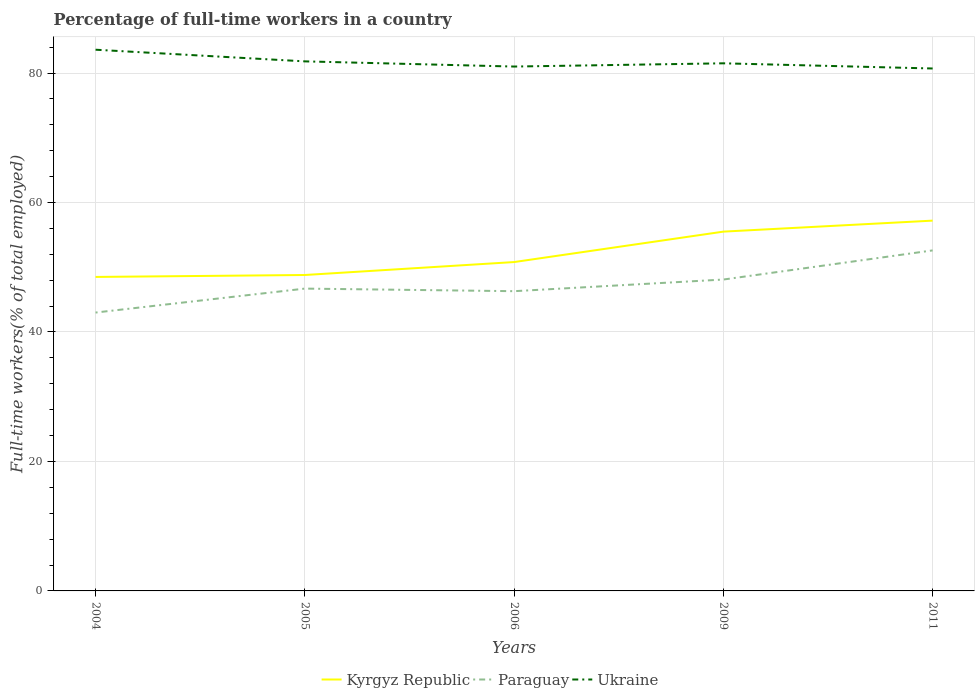How many different coloured lines are there?
Your response must be concise. 3. Does the line corresponding to Ukraine intersect with the line corresponding to Paraguay?
Provide a short and direct response. No. Across all years, what is the maximum percentage of full-time workers in Ukraine?
Your response must be concise. 80.7. What is the total percentage of full-time workers in Ukraine in the graph?
Keep it short and to the point. 2.6. What is the difference between the highest and the second highest percentage of full-time workers in Paraguay?
Your answer should be compact. 9.6. What is the difference between the highest and the lowest percentage of full-time workers in Paraguay?
Give a very brief answer. 2. Is the percentage of full-time workers in Paraguay strictly greater than the percentage of full-time workers in Kyrgyz Republic over the years?
Ensure brevity in your answer.  Yes. How many years are there in the graph?
Your response must be concise. 5. What is the difference between two consecutive major ticks on the Y-axis?
Your answer should be compact. 20. Does the graph contain any zero values?
Keep it short and to the point. No. How many legend labels are there?
Your answer should be very brief. 3. What is the title of the graph?
Offer a very short reply. Percentage of full-time workers in a country. What is the label or title of the X-axis?
Your response must be concise. Years. What is the label or title of the Y-axis?
Provide a succinct answer. Full-time workers(% of total employed). What is the Full-time workers(% of total employed) of Kyrgyz Republic in 2004?
Provide a short and direct response. 48.5. What is the Full-time workers(% of total employed) of Paraguay in 2004?
Ensure brevity in your answer.  43. What is the Full-time workers(% of total employed) of Ukraine in 2004?
Keep it short and to the point. 83.6. What is the Full-time workers(% of total employed) of Kyrgyz Republic in 2005?
Offer a very short reply. 48.8. What is the Full-time workers(% of total employed) in Paraguay in 2005?
Provide a short and direct response. 46.7. What is the Full-time workers(% of total employed) of Ukraine in 2005?
Offer a very short reply. 81.8. What is the Full-time workers(% of total employed) in Kyrgyz Republic in 2006?
Your response must be concise. 50.8. What is the Full-time workers(% of total employed) of Paraguay in 2006?
Ensure brevity in your answer.  46.3. What is the Full-time workers(% of total employed) in Ukraine in 2006?
Your answer should be very brief. 81. What is the Full-time workers(% of total employed) in Kyrgyz Republic in 2009?
Keep it short and to the point. 55.5. What is the Full-time workers(% of total employed) in Paraguay in 2009?
Provide a succinct answer. 48.1. What is the Full-time workers(% of total employed) of Ukraine in 2009?
Your response must be concise. 81.5. What is the Full-time workers(% of total employed) in Kyrgyz Republic in 2011?
Provide a succinct answer. 57.2. What is the Full-time workers(% of total employed) of Paraguay in 2011?
Your response must be concise. 52.6. What is the Full-time workers(% of total employed) of Ukraine in 2011?
Your answer should be compact. 80.7. Across all years, what is the maximum Full-time workers(% of total employed) of Kyrgyz Republic?
Provide a succinct answer. 57.2. Across all years, what is the maximum Full-time workers(% of total employed) of Paraguay?
Offer a terse response. 52.6. Across all years, what is the maximum Full-time workers(% of total employed) of Ukraine?
Offer a terse response. 83.6. Across all years, what is the minimum Full-time workers(% of total employed) in Kyrgyz Republic?
Your answer should be very brief. 48.5. Across all years, what is the minimum Full-time workers(% of total employed) in Paraguay?
Your response must be concise. 43. Across all years, what is the minimum Full-time workers(% of total employed) in Ukraine?
Make the answer very short. 80.7. What is the total Full-time workers(% of total employed) in Kyrgyz Republic in the graph?
Your response must be concise. 260.8. What is the total Full-time workers(% of total employed) in Paraguay in the graph?
Keep it short and to the point. 236.7. What is the total Full-time workers(% of total employed) of Ukraine in the graph?
Ensure brevity in your answer.  408.6. What is the difference between the Full-time workers(% of total employed) in Paraguay in 2004 and that in 2005?
Make the answer very short. -3.7. What is the difference between the Full-time workers(% of total employed) of Ukraine in 2004 and that in 2009?
Keep it short and to the point. 2.1. What is the difference between the Full-time workers(% of total employed) of Kyrgyz Republic in 2004 and that in 2011?
Your answer should be compact. -8.7. What is the difference between the Full-time workers(% of total employed) in Paraguay in 2004 and that in 2011?
Provide a short and direct response. -9.6. What is the difference between the Full-time workers(% of total employed) of Kyrgyz Republic in 2005 and that in 2006?
Provide a short and direct response. -2. What is the difference between the Full-time workers(% of total employed) in Ukraine in 2005 and that in 2006?
Provide a short and direct response. 0.8. What is the difference between the Full-time workers(% of total employed) of Ukraine in 2006 and that in 2009?
Keep it short and to the point. -0.5. What is the difference between the Full-time workers(% of total employed) of Paraguay in 2006 and that in 2011?
Make the answer very short. -6.3. What is the difference between the Full-time workers(% of total employed) of Kyrgyz Republic in 2004 and the Full-time workers(% of total employed) of Paraguay in 2005?
Your answer should be very brief. 1.8. What is the difference between the Full-time workers(% of total employed) of Kyrgyz Republic in 2004 and the Full-time workers(% of total employed) of Ukraine in 2005?
Offer a terse response. -33.3. What is the difference between the Full-time workers(% of total employed) of Paraguay in 2004 and the Full-time workers(% of total employed) of Ukraine in 2005?
Ensure brevity in your answer.  -38.8. What is the difference between the Full-time workers(% of total employed) in Kyrgyz Republic in 2004 and the Full-time workers(% of total employed) in Paraguay in 2006?
Provide a succinct answer. 2.2. What is the difference between the Full-time workers(% of total employed) of Kyrgyz Republic in 2004 and the Full-time workers(% of total employed) of Ukraine in 2006?
Provide a short and direct response. -32.5. What is the difference between the Full-time workers(% of total employed) in Paraguay in 2004 and the Full-time workers(% of total employed) in Ukraine in 2006?
Your response must be concise. -38. What is the difference between the Full-time workers(% of total employed) of Kyrgyz Republic in 2004 and the Full-time workers(% of total employed) of Paraguay in 2009?
Your answer should be compact. 0.4. What is the difference between the Full-time workers(% of total employed) in Kyrgyz Republic in 2004 and the Full-time workers(% of total employed) in Ukraine in 2009?
Keep it short and to the point. -33. What is the difference between the Full-time workers(% of total employed) in Paraguay in 2004 and the Full-time workers(% of total employed) in Ukraine in 2009?
Offer a terse response. -38.5. What is the difference between the Full-time workers(% of total employed) of Kyrgyz Republic in 2004 and the Full-time workers(% of total employed) of Ukraine in 2011?
Give a very brief answer. -32.2. What is the difference between the Full-time workers(% of total employed) of Paraguay in 2004 and the Full-time workers(% of total employed) of Ukraine in 2011?
Give a very brief answer. -37.7. What is the difference between the Full-time workers(% of total employed) of Kyrgyz Republic in 2005 and the Full-time workers(% of total employed) of Ukraine in 2006?
Provide a succinct answer. -32.2. What is the difference between the Full-time workers(% of total employed) in Paraguay in 2005 and the Full-time workers(% of total employed) in Ukraine in 2006?
Give a very brief answer. -34.3. What is the difference between the Full-time workers(% of total employed) of Kyrgyz Republic in 2005 and the Full-time workers(% of total employed) of Ukraine in 2009?
Offer a very short reply. -32.7. What is the difference between the Full-time workers(% of total employed) in Paraguay in 2005 and the Full-time workers(% of total employed) in Ukraine in 2009?
Offer a very short reply. -34.8. What is the difference between the Full-time workers(% of total employed) of Kyrgyz Republic in 2005 and the Full-time workers(% of total employed) of Paraguay in 2011?
Provide a short and direct response. -3.8. What is the difference between the Full-time workers(% of total employed) of Kyrgyz Republic in 2005 and the Full-time workers(% of total employed) of Ukraine in 2011?
Ensure brevity in your answer.  -31.9. What is the difference between the Full-time workers(% of total employed) in Paraguay in 2005 and the Full-time workers(% of total employed) in Ukraine in 2011?
Make the answer very short. -34. What is the difference between the Full-time workers(% of total employed) of Kyrgyz Republic in 2006 and the Full-time workers(% of total employed) of Ukraine in 2009?
Make the answer very short. -30.7. What is the difference between the Full-time workers(% of total employed) in Paraguay in 2006 and the Full-time workers(% of total employed) in Ukraine in 2009?
Your response must be concise. -35.2. What is the difference between the Full-time workers(% of total employed) of Kyrgyz Republic in 2006 and the Full-time workers(% of total employed) of Ukraine in 2011?
Provide a succinct answer. -29.9. What is the difference between the Full-time workers(% of total employed) of Paraguay in 2006 and the Full-time workers(% of total employed) of Ukraine in 2011?
Make the answer very short. -34.4. What is the difference between the Full-time workers(% of total employed) in Kyrgyz Republic in 2009 and the Full-time workers(% of total employed) in Paraguay in 2011?
Your answer should be very brief. 2.9. What is the difference between the Full-time workers(% of total employed) of Kyrgyz Republic in 2009 and the Full-time workers(% of total employed) of Ukraine in 2011?
Your response must be concise. -25.2. What is the difference between the Full-time workers(% of total employed) in Paraguay in 2009 and the Full-time workers(% of total employed) in Ukraine in 2011?
Provide a short and direct response. -32.6. What is the average Full-time workers(% of total employed) of Kyrgyz Republic per year?
Offer a terse response. 52.16. What is the average Full-time workers(% of total employed) in Paraguay per year?
Provide a succinct answer. 47.34. What is the average Full-time workers(% of total employed) in Ukraine per year?
Your response must be concise. 81.72. In the year 2004, what is the difference between the Full-time workers(% of total employed) of Kyrgyz Republic and Full-time workers(% of total employed) of Paraguay?
Your answer should be very brief. 5.5. In the year 2004, what is the difference between the Full-time workers(% of total employed) of Kyrgyz Republic and Full-time workers(% of total employed) of Ukraine?
Make the answer very short. -35.1. In the year 2004, what is the difference between the Full-time workers(% of total employed) in Paraguay and Full-time workers(% of total employed) in Ukraine?
Make the answer very short. -40.6. In the year 2005, what is the difference between the Full-time workers(% of total employed) in Kyrgyz Republic and Full-time workers(% of total employed) in Paraguay?
Your answer should be very brief. 2.1. In the year 2005, what is the difference between the Full-time workers(% of total employed) in Kyrgyz Republic and Full-time workers(% of total employed) in Ukraine?
Give a very brief answer. -33. In the year 2005, what is the difference between the Full-time workers(% of total employed) of Paraguay and Full-time workers(% of total employed) of Ukraine?
Your response must be concise. -35.1. In the year 2006, what is the difference between the Full-time workers(% of total employed) in Kyrgyz Republic and Full-time workers(% of total employed) in Ukraine?
Your response must be concise. -30.2. In the year 2006, what is the difference between the Full-time workers(% of total employed) of Paraguay and Full-time workers(% of total employed) of Ukraine?
Provide a succinct answer. -34.7. In the year 2009, what is the difference between the Full-time workers(% of total employed) in Kyrgyz Republic and Full-time workers(% of total employed) in Paraguay?
Ensure brevity in your answer.  7.4. In the year 2009, what is the difference between the Full-time workers(% of total employed) of Paraguay and Full-time workers(% of total employed) of Ukraine?
Your answer should be compact. -33.4. In the year 2011, what is the difference between the Full-time workers(% of total employed) of Kyrgyz Republic and Full-time workers(% of total employed) of Paraguay?
Give a very brief answer. 4.6. In the year 2011, what is the difference between the Full-time workers(% of total employed) of Kyrgyz Republic and Full-time workers(% of total employed) of Ukraine?
Your response must be concise. -23.5. In the year 2011, what is the difference between the Full-time workers(% of total employed) of Paraguay and Full-time workers(% of total employed) of Ukraine?
Offer a very short reply. -28.1. What is the ratio of the Full-time workers(% of total employed) in Kyrgyz Republic in 2004 to that in 2005?
Offer a terse response. 0.99. What is the ratio of the Full-time workers(% of total employed) in Paraguay in 2004 to that in 2005?
Your answer should be compact. 0.92. What is the ratio of the Full-time workers(% of total employed) of Ukraine in 2004 to that in 2005?
Offer a very short reply. 1.02. What is the ratio of the Full-time workers(% of total employed) of Kyrgyz Republic in 2004 to that in 2006?
Your response must be concise. 0.95. What is the ratio of the Full-time workers(% of total employed) of Paraguay in 2004 to that in 2006?
Provide a short and direct response. 0.93. What is the ratio of the Full-time workers(% of total employed) of Ukraine in 2004 to that in 2006?
Provide a succinct answer. 1.03. What is the ratio of the Full-time workers(% of total employed) of Kyrgyz Republic in 2004 to that in 2009?
Your response must be concise. 0.87. What is the ratio of the Full-time workers(% of total employed) of Paraguay in 2004 to that in 2009?
Give a very brief answer. 0.89. What is the ratio of the Full-time workers(% of total employed) in Ukraine in 2004 to that in 2009?
Provide a succinct answer. 1.03. What is the ratio of the Full-time workers(% of total employed) in Kyrgyz Republic in 2004 to that in 2011?
Provide a short and direct response. 0.85. What is the ratio of the Full-time workers(% of total employed) in Paraguay in 2004 to that in 2011?
Give a very brief answer. 0.82. What is the ratio of the Full-time workers(% of total employed) of Ukraine in 2004 to that in 2011?
Your answer should be very brief. 1.04. What is the ratio of the Full-time workers(% of total employed) in Kyrgyz Republic in 2005 to that in 2006?
Give a very brief answer. 0.96. What is the ratio of the Full-time workers(% of total employed) of Paraguay in 2005 to that in 2006?
Offer a very short reply. 1.01. What is the ratio of the Full-time workers(% of total employed) in Ukraine in 2005 to that in 2006?
Keep it short and to the point. 1.01. What is the ratio of the Full-time workers(% of total employed) of Kyrgyz Republic in 2005 to that in 2009?
Make the answer very short. 0.88. What is the ratio of the Full-time workers(% of total employed) in Paraguay in 2005 to that in 2009?
Offer a terse response. 0.97. What is the ratio of the Full-time workers(% of total employed) in Ukraine in 2005 to that in 2009?
Your answer should be compact. 1. What is the ratio of the Full-time workers(% of total employed) in Kyrgyz Republic in 2005 to that in 2011?
Your answer should be very brief. 0.85. What is the ratio of the Full-time workers(% of total employed) of Paraguay in 2005 to that in 2011?
Give a very brief answer. 0.89. What is the ratio of the Full-time workers(% of total employed) in Ukraine in 2005 to that in 2011?
Your answer should be compact. 1.01. What is the ratio of the Full-time workers(% of total employed) in Kyrgyz Republic in 2006 to that in 2009?
Your response must be concise. 0.92. What is the ratio of the Full-time workers(% of total employed) in Paraguay in 2006 to that in 2009?
Your answer should be compact. 0.96. What is the ratio of the Full-time workers(% of total employed) in Ukraine in 2006 to that in 2009?
Make the answer very short. 0.99. What is the ratio of the Full-time workers(% of total employed) in Kyrgyz Republic in 2006 to that in 2011?
Your response must be concise. 0.89. What is the ratio of the Full-time workers(% of total employed) in Paraguay in 2006 to that in 2011?
Ensure brevity in your answer.  0.88. What is the ratio of the Full-time workers(% of total employed) of Ukraine in 2006 to that in 2011?
Your answer should be compact. 1. What is the ratio of the Full-time workers(% of total employed) of Kyrgyz Republic in 2009 to that in 2011?
Your response must be concise. 0.97. What is the ratio of the Full-time workers(% of total employed) in Paraguay in 2009 to that in 2011?
Provide a succinct answer. 0.91. What is the ratio of the Full-time workers(% of total employed) of Ukraine in 2009 to that in 2011?
Provide a succinct answer. 1.01. What is the difference between the highest and the second highest Full-time workers(% of total employed) in Kyrgyz Republic?
Make the answer very short. 1.7. What is the difference between the highest and the second highest Full-time workers(% of total employed) of Paraguay?
Your response must be concise. 4.5. What is the difference between the highest and the lowest Full-time workers(% of total employed) of Kyrgyz Republic?
Ensure brevity in your answer.  8.7. What is the difference between the highest and the lowest Full-time workers(% of total employed) of Paraguay?
Provide a succinct answer. 9.6. What is the difference between the highest and the lowest Full-time workers(% of total employed) in Ukraine?
Offer a terse response. 2.9. 